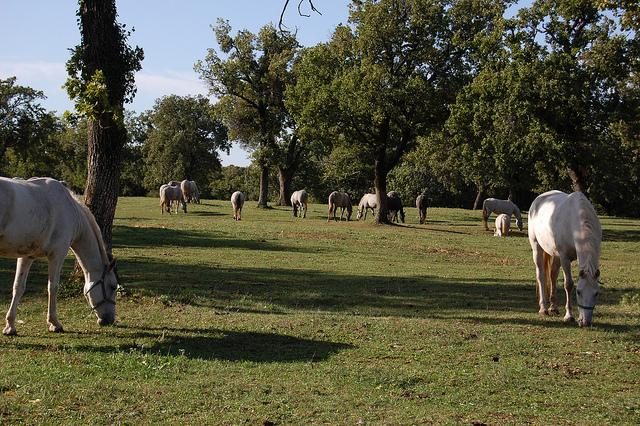What animals are present?

Choices:
A) giraffe
B) deer
C) dog
D) horse horse 